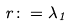Convert formula to latex. <formula><loc_0><loc_0><loc_500><loc_500>r \colon = \lambda _ { 1 }</formula> 